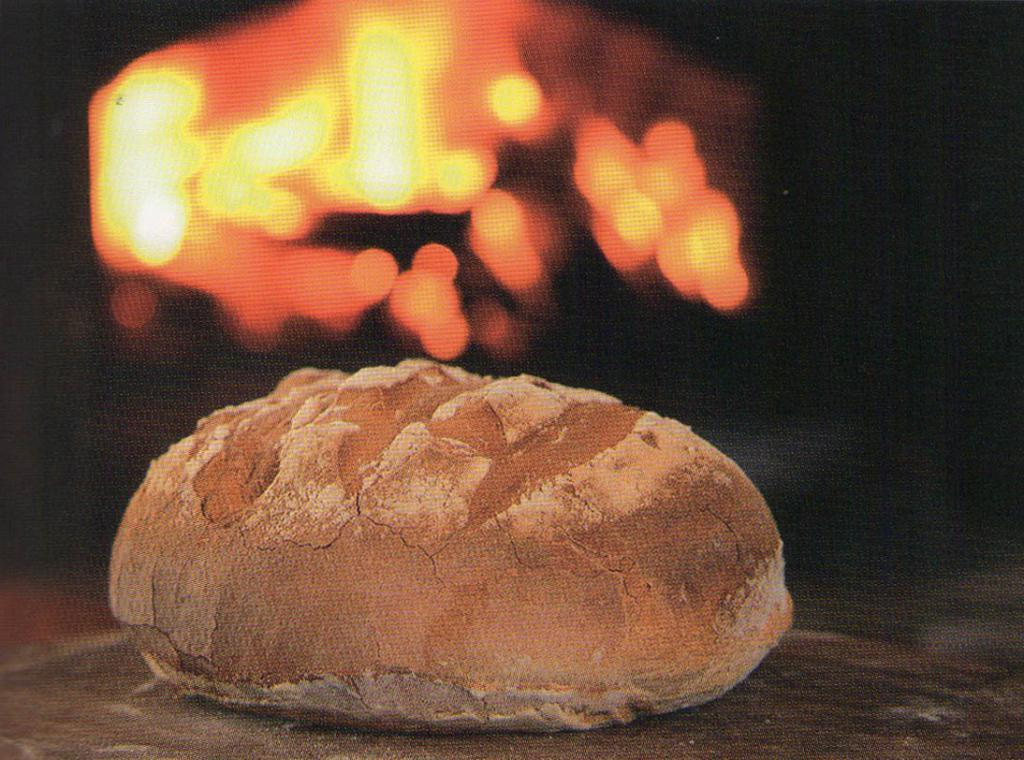What is the main subject of the image? There is a food item in the image. Where is the food item located? The food item is on a surface. What can be seen in the background of the image? There is fire visible in the background of the image. How many volleyballs are being used to cook the food in the image? There are no volleyballs present in the image, and they are not being used to cook the food. 